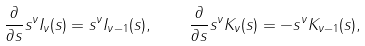Convert formula to latex. <formula><loc_0><loc_0><loc_500><loc_500>\frac { \partial } { \partial s } s ^ { \nu } I _ { \nu } ( s ) = s ^ { \nu } I _ { \nu - 1 } ( s ) , \quad \frac { \partial } { \partial s } s ^ { \nu } K _ { \nu } ( s ) = - s ^ { \nu } K _ { \nu - 1 } ( s ) ,</formula> 